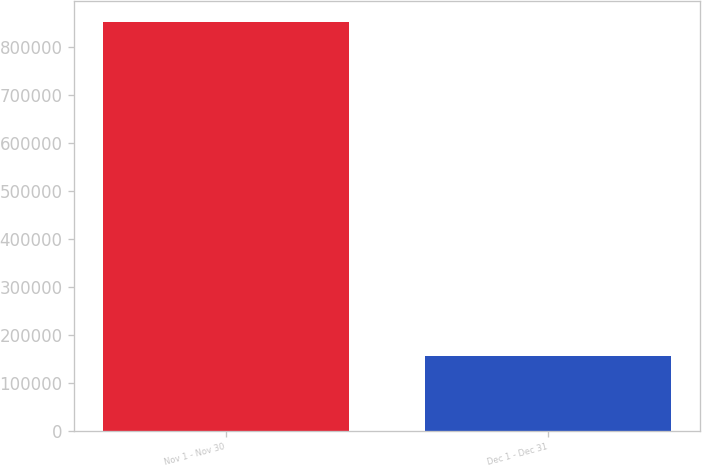<chart> <loc_0><loc_0><loc_500><loc_500><bar_chart><fcel>Nov 1 - Nov 30<fcel>Dec 1 - Dec 31<nl><fcel>852043<fcel>156686<nl></chart> 